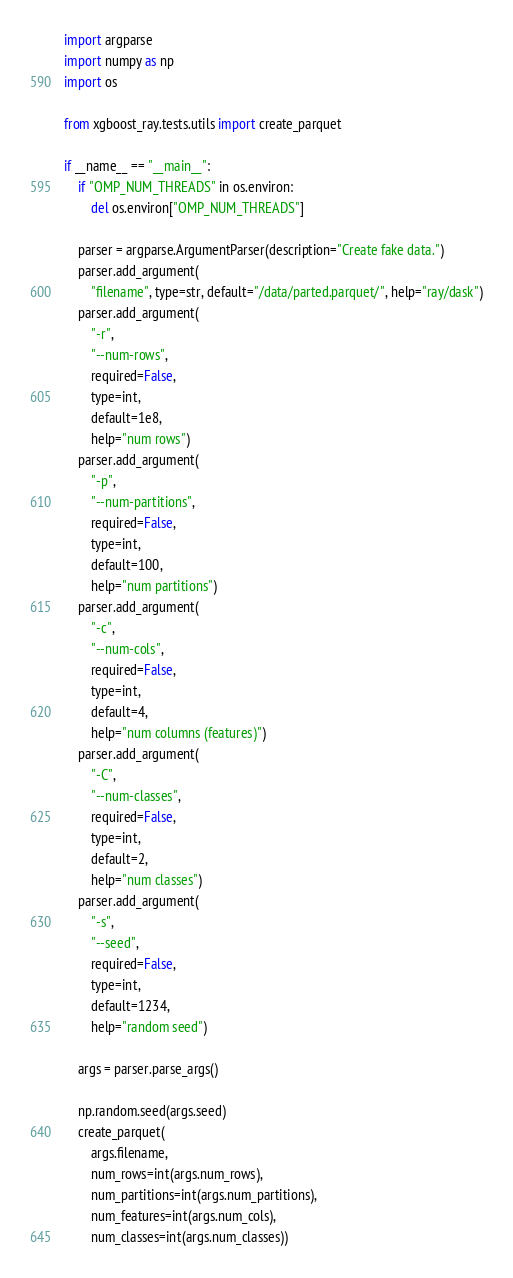Convert code to text. <code><loc_0><loc_0><loc_500><loc_500><_Python_>import argparse
import numpy as np
import os

from xgboost_ray.tests.utils import create_parquet

if __name__ == "__main__":
    if "OMP_NUM_THREADS" in os.environ:
        del os.environ["OMP_NUM_THREADS"]

    parser = argparse.ArgumentParser(description="Create fake data.")
    parser.add_argument(
        "filename", type=str, default="/data/parted.parquet/", help="ray/dask")
    parser.add_argument(
        "-r",
        "--num-rows",
        required=False,
        type=int,
        default=1e8,
        help="num rows")
    parser.add_argument(
        "-p",
        "--num-partitions",
        required=False,
        type=int,
        default=100,
        help="num partitions")
    parser.add_argument(
        "-c",
        "--num-cols",
        required=False,
        type=int,
        default=4,
        help="num columns (features)")
    parser.add_argument(
        "-C",
        "--num-classes",
        required=False,
        type=int,
        default=2,
        help="num classes")
    parser.add_argument(
        "-s",
        "--seed",
        required=False,
        type=int,
        default=1234,
        help="random seed")

    args = parser.parse_args()

    np.random.seed(args.seed)
    create_parquet(
        args.filename,
        num_rows=int(args.num_rows),
        num_partitions=int(args.num_partitions),
        num_features=int(args.num_cols),
        num_classes=int(args.num_classes))
</code> 